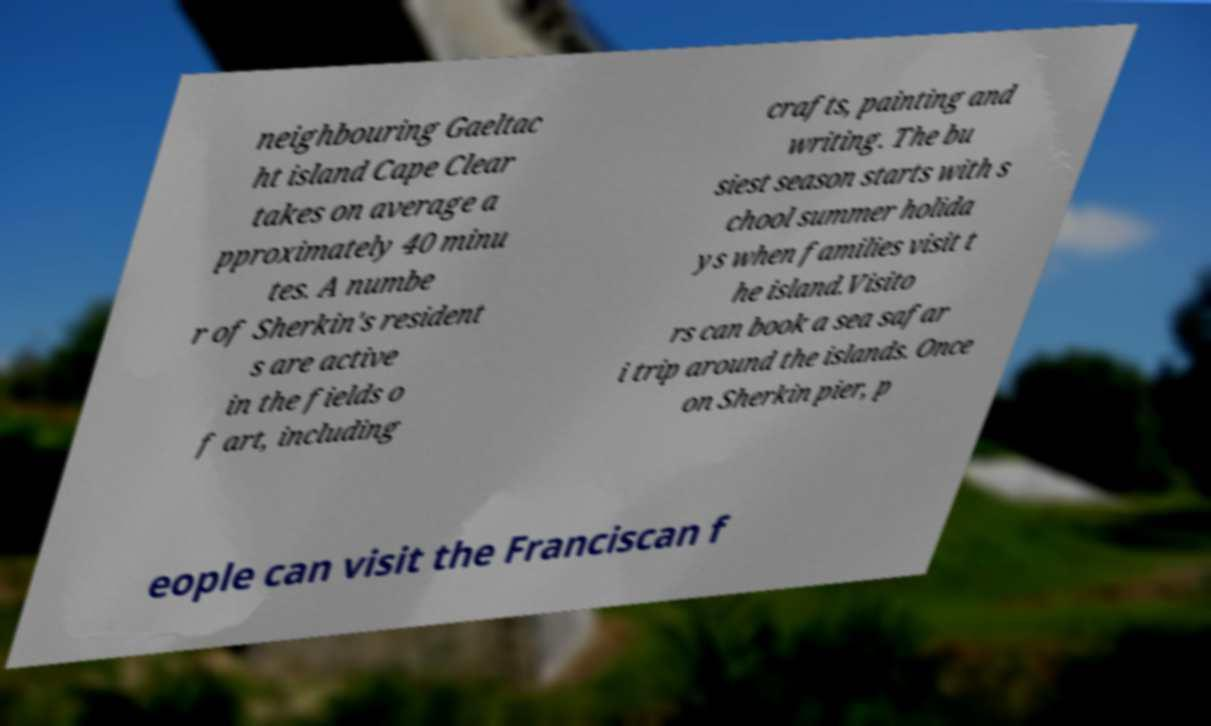For documentation purposes, I need the text within this image transcribed. Could you provide that? neighbouring Gaeltac ht island Cape Clear takes on average a pproximately 40 minu tes. A numbe r of Sherkin's resident s are active in the fields o f art, including crafts, painting and writing. The bu siest season starts with s chool summer holida ys when families visit t he island.Visito rs can book a sea safar i trip around the islands. Once on Sherkin pier, p eople can visit the Franciscan f 